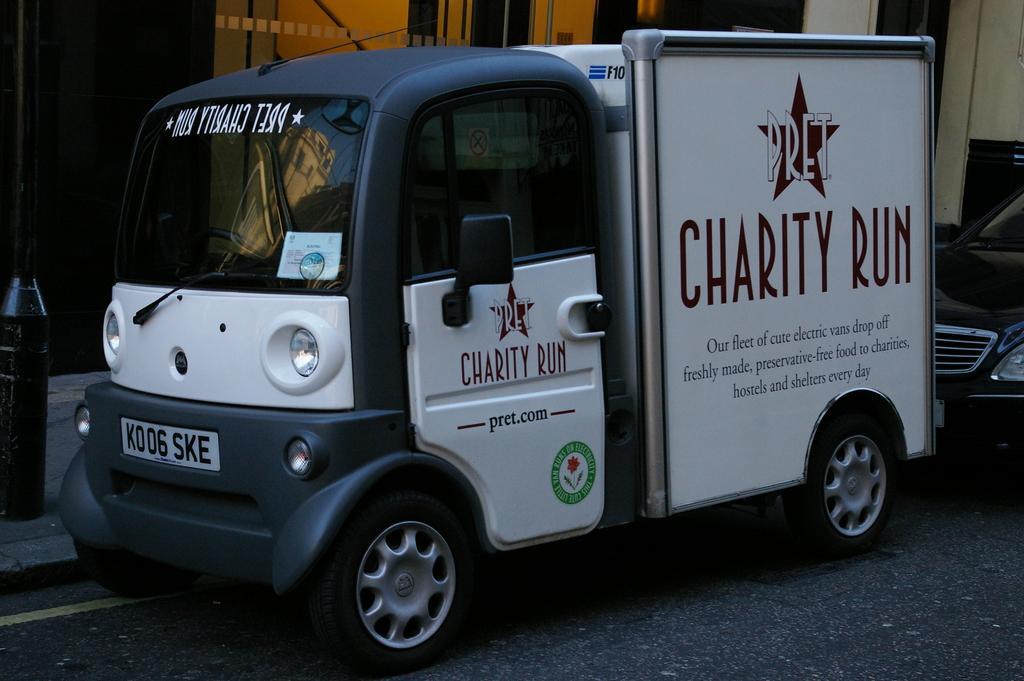Can you describe this image briefly? In this image we can see vehicles. On the vehicle there is text. Also there are logos. In the back there is a building. Also we can see a pole. 